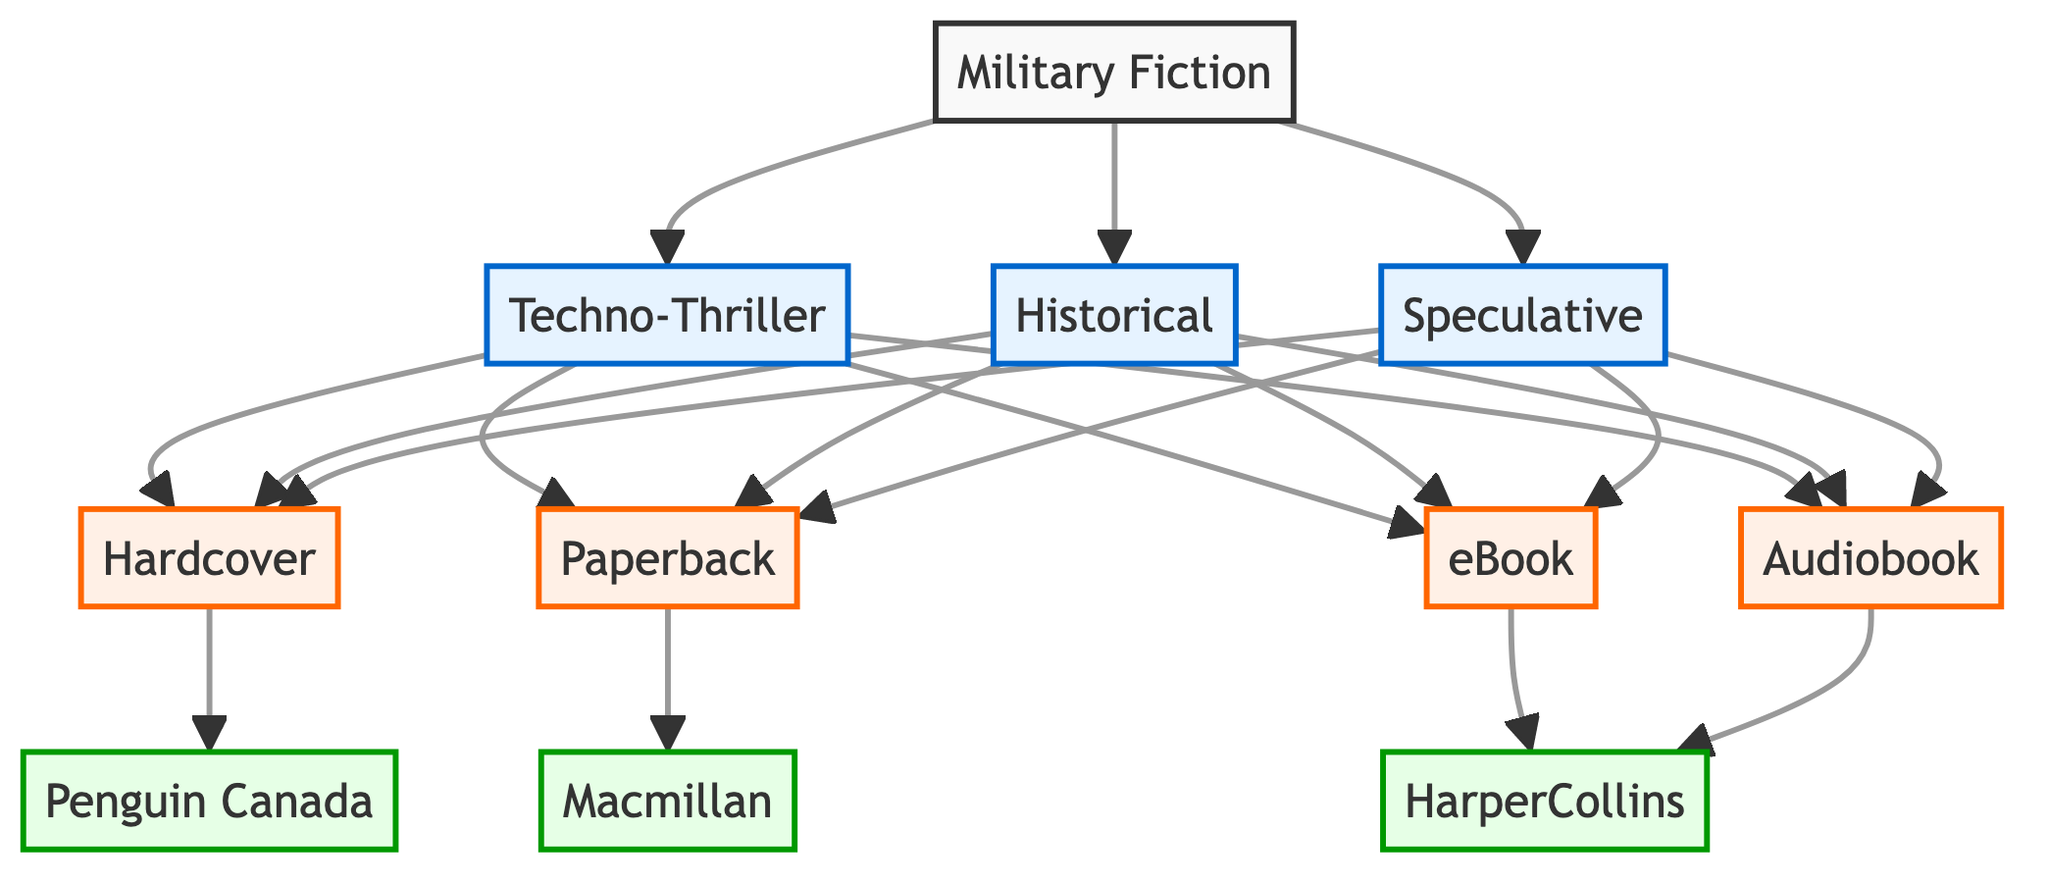What are the subgenres of Military Fiction? The diagram identifies three subgenres branching from Military Fiction: Techno-Thriller, Historical, and Speculative. These subgenres are clearly labeled and formatted differently in the diagram, making them easily identifiable.
Answer: Techno-Thriller, Historical, Speculative How many formats are associated with the Techno-Thriller subgenre? In the diagram, the Techno-Thriller subgenre points to four formats: Hardcover, Paperback, eBook, and Audiobook. Each format is connected with lines indicating the relationship.
Answer: 4 Which publisher is associated with eBooks? The diagram shows that the eBook format is linked to HarperCollins, indicating this publisher's exclusive association with this format. This connection is represented as a direct line from the eBook node to the HarperCollins node.
Answer: HarperCollins What is the relationship between Military Fiction and its subgenres? The diagram illustrates a direct relationship where Military Fiction is the parent node linked to its three subgenres. Each subgenre directly branches out from the Military Fiction node, representing their classification under this genre.
Answer: Parent-Child Which format is associated with the Macmillan publisher? According to the diagram, the Paperback format is specifically linked to Macmillan, highlighted by a direct line connecting these two nodes in the flowchart.
Answer: Paperback Identify one genre that has multiple formats available. The Historical subgenre is shown in the diagram to have four associated formats: Hardcover, Paperback, eBook, and Audiobook, illustrating that it spans across various reading options.
Answer: Historical How many total nodes are there related to formats in the diagram? The diagram lists four formats: Hardcover, Paperback, eBook, and Audiobook. Each format is represented as a node, and summing these gives a total of four.
Answer: 4 What type of diagram is used for this representation? The flowchart is explicitly labeled as a flowchart diagram in the code and visually represents the breakdown of genres and formats in Military Fiction, following the conventions typical of flowcharts.
Answer: Flowchart 